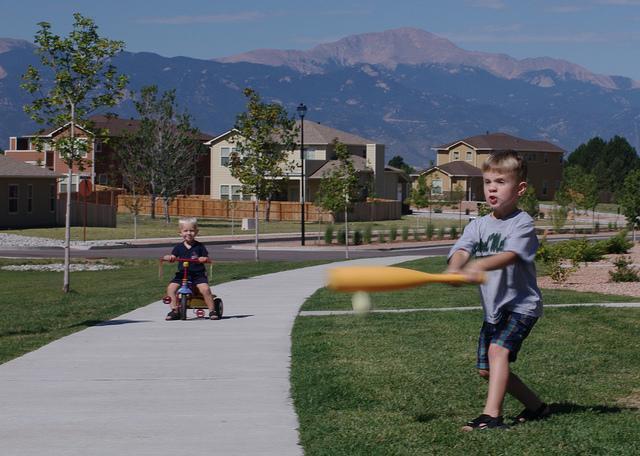What is the child travelling on?
Indicate the correct choice and explain in the format: 'Answer: answer
Rationale: rationale.'
Options: Hummer, tricycle, monster truck, tank. Answer: tricycle.
Rationale: The child is on a tricycle. 